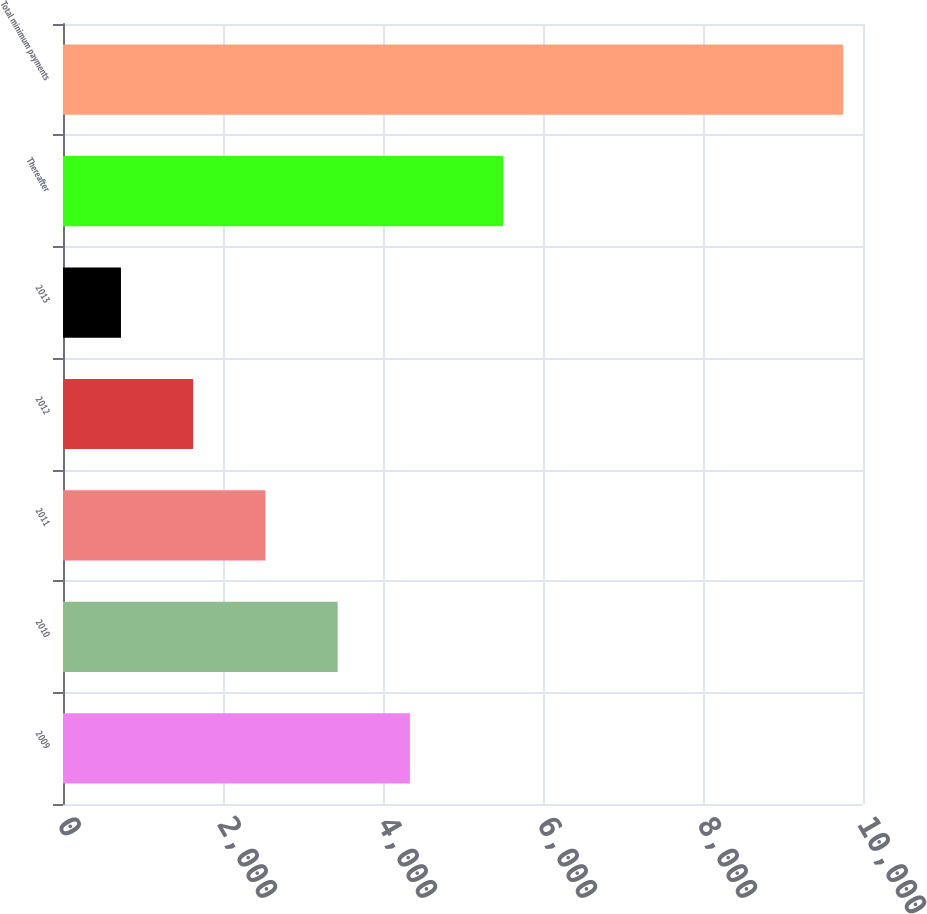Convert chart to OTSL. <chart><loc_0><loc_0><loc_500><loc_500><bar_chart><fcel>2009<fcel>2010<fcel>2011<fcel>2012<fcel>2013<fcel>Thereafter<fcel>Total minimum payments<nl><fcel>4335.78<fcel>3432.96<fcel>2530.14<fcel>1627.32<fcel>724.5<fcel>5500<fcel>9752.7<nl></chart> 